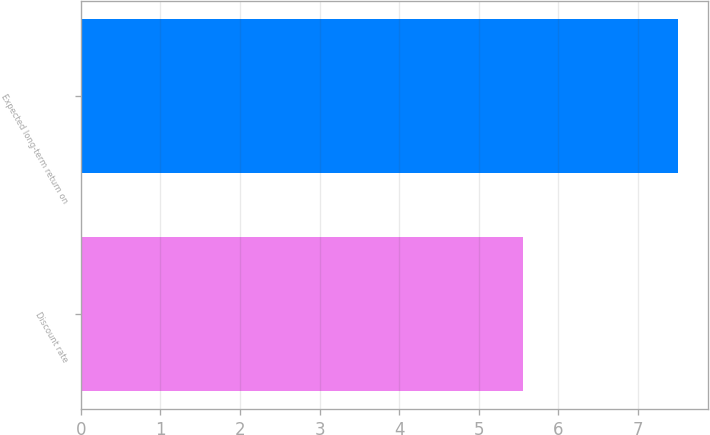Convert chart. <chart><loc_0><loc_0><loc_500><loc_500><bar_chart><fcel>Discount rate<fcel>Expected long-term return on<nl><fcel>5.55<fcel>7.5<nl></chart> 